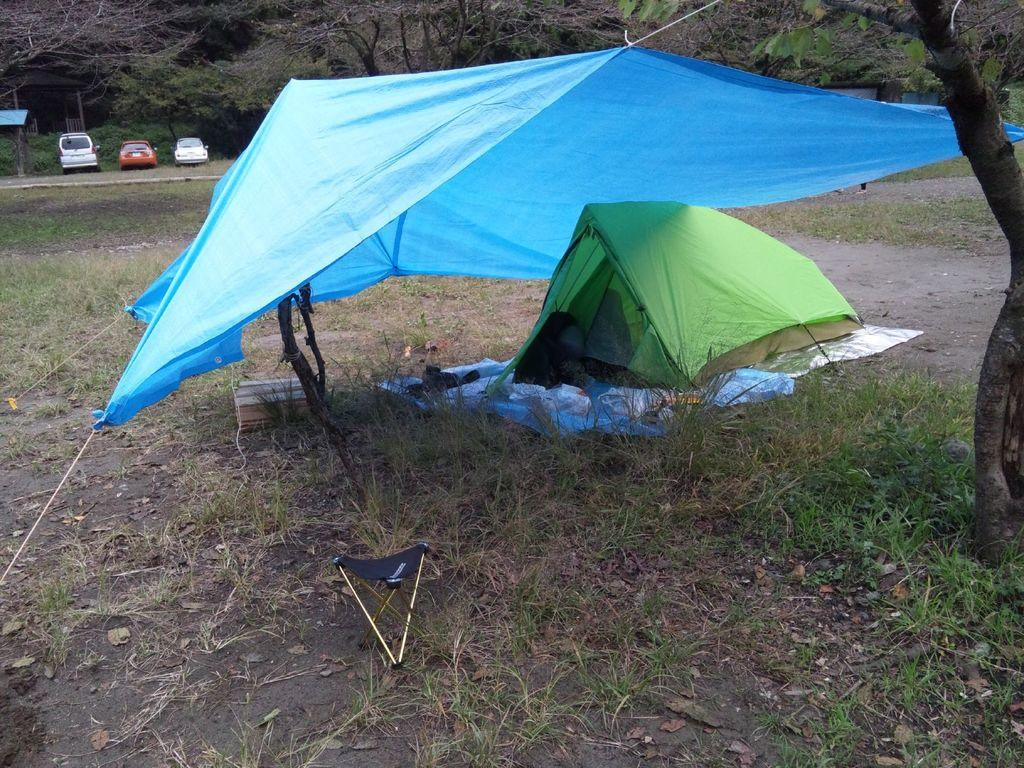What type of temporary shelters can be seen in the image? There are tents in the image. Can you describe the appearance of the tents? The tents are in different colors. What other natural elements are present in the image? There are trees in the image. What man-made objects can be seen in the image? There are vehicles and a shed in the image. What time of day is the discussion taking place in the image? There is no discussion taking place in the image, as it features tents, trees, vehicles, and a shed. Is there any indication of an attack happening in the image? There is no indication of an attack in the image; it shows a peaceful scene with tents, trees, vehicles, and a shed. 